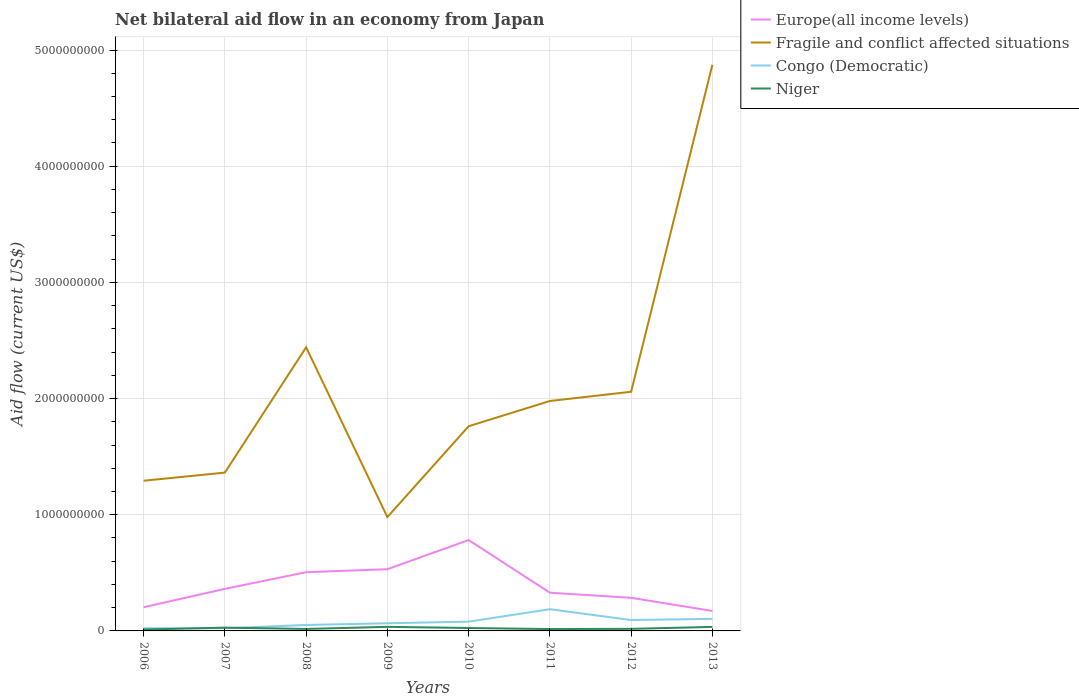How many different coloured lines are there?
Ensure brevity in your answer.  4. Across all years, what is the maximum net bilateral aid flow in Fragile and conflict affected situations?
Your response must be concise. 9.80e+08. In which year was the net bilateral aid flow in Europe(all income levels) maximum?
Offer a very short reply. 2013. What is the total net bilateral aid flow in Europe(all income levels) in the graph?
Give a very brief answer. 2.02e+08. What is the difference between the highest and the second highest net bilateral aid flow in Niger?
Give a very brief answer. 2.30e+07. What is the difference between the highest and the lowest net bilateral aid flow in Congo (Democratic)?
Provide a short and direct response. 4. How many lines are there?
Your answer should be compact. 4. How many years are there in the graph?
Give a very brief answer. 8. Where does the legend appear in the graph?
Keep it short and to the point. Top right. How many legend labels are there?
Your response must be concise. 4. How are the legend labels stacked?
Offer a terse response. Vertical. What is the title of the graph?
Your response must be concise. Net bilateral aid flow in an economy from Japan. Does "High income: OECD" appear as one of the legend labels in the graph?
Make the answer very short. No. What is the label or title of the X-axis?
Give a very brief answer. Years. What is the label or title of the Y-axis?
Your answer should be very brief. Aid flow (current US$). What is the Aid flow (current US$) in Europe(all income levels) in 2006?
Keep it short and to the point. 2.04e+08. What is the Aid flow (current US$) in Fragile and conflict affected situations in 2006?
Offer a terse response. 1.29e+09. What is the Aid flow (current US$) in Congo (Democratic) in 2006?
Your answer should be very brief. 2.32e+07. What is the Aid flow (current US$) in Niger in 2006?
Ensure brevity in your answer.  1.21e+07. What is the Aid flow (current US$) in Europe(all income levels) in 2007?
Your answer should be compact. 3.62e+08. What is the Aid flow (current US$) of Fragile and conflict affected situations in 2007?
Keep it short and to the point. 1.36e+09. What is the Aid flow (current US$) of Congo (Democratic) in 2007?
Ensure brevity in your answer.  2.29e+07. What is the Aid flow (current US$) in Niger in 2007?
Your answer should be very brief. 2.83e+07. What is the Aid flow (current US$) in Europe(all income levels) in 2008?
Ensure brevity in your answer.  5.05e+08. What is the Aid flow (current US$) of Fragile and conflict affected situations in 2008?
Your answer should be compact. 2.44e+09. What is the Aid flow (current US$) of Congo (Democratic) in 2008?
Offer a terse response. 5.12e+07. What is the Aid flow (current US$) of Niger in 2008?
Make the answer very short. 1.69e+07. What is the Aid flow (current US$) in Europe(all income levels) in 2009?
Provide a succinct answer. 5.31e+08. What is the Aid flow (current US$) of Fragile and conflict affected situations in 2009?
Offer a very short reply. 9.80e+08. What is the Aid flow (current US$) of Congo (Democratic) in 2009?
Your answer should be compact. 6.57e+07. What is the Aid flow (current US$) in Niger in 2009?
Ensure brevity in your answer.  3.51e+07. What is the Aid flow (current US$) in Europe(all income levels) in 2010?
Keep it short and to the point. 7.82e+08. What is the Aid flow (current US$) of Fragile and conflict affected situations in 2010?
Your answer should be very brief. 1.76e+09. What is the Aid flow (current US$) of Congo (Democratic) in 2010?
Provide a succinct answer. 8.00e+07. What is the Aid flow (current US$) in Niger in 2010?
Provide a short and direct response. 2.52e+07. What is the Aid flow (current US$) of Europe(all income levels) in 2011?
Your response must be concise. 3.29e+08. What is the Aid flow (current US$) in Fragile and conflict affected situations in 2011?
Ensure brevity in your answer.  1.98e+09. What is the Aid flow (current US$) of Congo (Democratic) in 2011?
Offer a terse response. 1.87e+08. What is the Aid flow (current US$) of Niger in 2011?
Your response must be concise. 1.59e+07. What is the Aid flow (current US$) in Europe(all income levels) in 2012?
Offer a very short reply. 2.85e+08. What is the Aid flow (current US$) of Fragile and conflict affected situations in 2012?
Keep it short and to the point. 2.06e+09. What is the Aid flow (current US$) in Congo (Democratic) in 2012?
Provide a succinct answer. 9.39e+07. What is the Aid flow (current US$) of Niger in 2012?
Offer a very short reply. 1.79e+07. What is the Aid flow (current US$) of Europe(all income levels) in 2013?
Make the answer very short. 1.72e+08. What is the Aid flow (current US$) in Fragile and conflict affected situations in 2013?
Your answer should be compact. 4.87e+09. What is the Aid flow (current US$) of Congo (Democratic) in 2013?
Make the answer very short. 1.04e+08. What is the Aid flow (current US$) of Niger in 2013?
Give a very brief answer. 3.45e+07. Across all years, what is the maximum Aid flow (current US$) in Europe(all income levels)?
Offer a terse response. 7.82e+08. Across all years, what is the maximum Aid flow (current US$) in Fragile and conflict affected situations?
Offer a very short reply. 4.87e+09. Across all years, what is the maximum Aid flow (current US$) of Congo (Democratic)?
Keep it short and to the point. 1.87e+08. Across all years, what is the maximum Aid flow (current US$) in Niger?
Your response must be concise. 3.51e+07. Across all years, what is the minimum Aid flow (current US$) of Europe(all income levels)?
Ensure brevity in your answer.  1.72e+08. Across all years, what is the minimum Aid flow (current US$) of Fragile and conflict affected situations?
Your answer should be very brief. 9.80e+08. Across all years, what is the minimum Aid flow (current US$) in Congo (Democratic)?
Your answer should be very brief. 2.29e+07. Across all years, what is the minimum Aid flow (current US$) in Niger?
Make the answer very short. 1.21e+07. What is the total Aid flow (current US$) of Europe(all income levels) in the graph?
Your answer should be compact. 3.17e+09. What is the total Aid flow (current US$) of Fragile and conflict affected situations in the graph?
Your response must be concise. 1.67e+1. What is the total Aid flow (current US$) in Congo (Democratic) in the graph?
Provide a short and direct response. 6.27e+08. What is the total Aid flow (current US$) of Niger in the graph?
Your answer should be very brief. 1.86e+08. What is the difference between the Aid flow (current US$) in Europe(all income levels) in 2006 and that in 2007?
Make the answer very short. -1.58e+08. What is the difference between the Aid flow (current US$) of Fragile and conflict affected situations in 2006 and that in 2007?
Your response must be concise. -7.00e+07. What is the difference between the Aid flow (current US$) of Congo (Democratic) in 2006 and that in 2007?
Your answer should be very brief. 2.30e+05. What is the difference between the Aid flow (current US$) in Niger in 2006 and that in 2007?
Provide a succinct answer. -1.62e+07. What is the difference between the Aid flow (current US$) in Europe(all income levels) in 2006 and that in 2008?
Offer a very short reply. -3.01e+08. What is the difference between the Aid flow (current US$) of Fragile and conflict affected situations in 2006 and that in 2008?
Your answer should be very brief. -1.15e+09. What is the difference between the Aid flow (current US$) in Congo (Democratic) in 2006 and that in 2008?
Your answer should be compact. -2.81e+07. What is the difference between the Aid flow (current US$) in Niger in 2006 and that in 2008?
Provide a short and direct response. -4.84e+06. What is the difference between the Aid flow (current US$) in Europe(all income levels) in 2006 and that in 2009?
Your answer should be compact. -3.27e+08. What is the difference between the Aid flow (current US$) of Fragile and conflict affected situations in 2006 and that in 2009?
Your answer should be very brief. 3.13e+08. What is the difference between the Aid flow (current US$) of Congo (Democratic) in 2006 and that in 2009?
Keep it short and to the point. -4.25e+07. What is the difference between the Aid flow (current US$) in Niger in 2006 and that in 2009?
Offer a terse response. -2.30e+07. What is the difference between the Aid flow (current US$) of Europe(all income levels) in 2006 and that in 2010?
Your answer should be compact. -5.78e+08. What is the difference between the Aid flow (current US$) of Fragile and conflict affected situations in 2006 and that in 2010?
Offer a very short reply. -4.69e+08. What is the difference between the Aid flow (current US$) of Congo (Democratic) in 2006 and that in 2010?
Your answer should be compact. -5.68e+07. What is the difference between the Aid flow (current US$) in Niger in 2006 and that in 2010?
Give a very brief answer. -1.31e+07. What is the difference between the Aid flow (current US$) of Europe(all income levels) in 2006 and that in 2011?
Your answer should be very brief. -1.25e+08. What is the difference between the Aid flow (current US$) of Fragile and conflict affected situations in 2006 and that in 2011?
Your response must be concise. -6.86e+08. What is the difference between the Aid flow (current US$) of Congo (Democratic) in 2006 and that in 2011?
Ensure brevity in your answer.  -1.64e+08. What is the difference between the Aid flow (current US$) of Niger in 2006 and that in 2011?
Keep it short and to the point. -3.77e+06. What is the difference between the Aid flow (current US$) in Europe(all income levels) in 2006 and that in 2012?
Provide a short and direct response. -8.10e+07. What is the difference between the Aid flow (current US$) of Fragile and conflict affected situations in 2006 and that in 2012?
Keep it short and to the point. -7.66e+08. What is the difference between the Aid flow (current US$) in Congo (Democratic) in 2006 and that in 2012?
Offer a terse response. -7.07e+07. What is the difference between the Aid flow (current US$) in Niger in 2006 and that in 2012?
Make the answer very short. -5.77e+06. What is the difference between the Aid flow (current US$) in Europe(all income levels) in 2006 and that in 2013?
Offer a terse response. 3.23e+07. What is the difference between the Aid flow (current US$) of Fragile and conflict affected situations in 2006 and that in 2013?
Offer a terse response. -3.58e+09. What is the difference between the Aid flow (current US$) in Congo (Democratic) in 2006 and that in 2013?
Provide a short and direct response. -8.06e+07. What is the difference between the Aid flow (current US$) of Niger in 2006 and that in 2013?
Provide a succinct answer. -2.24e+07. What is the difference between the Aid flow (current US$) in Europe(all income levels) in 2007 and that in 2008?
Provide a short and direct response. -1.43e+08. What is the difference between the Aid flow (current US$) in Fragile and conflict affected situations in 2007 and that in 2008?
Your response must be concise. -1.08e+09. What is the difference between the Aid flow (current US$) of Congo (Democratic) in 2007 and that in 2008?
Provide a succinct answer. -2.83e+07. What is the difference between the Aid flow (current US$) of Niger in 2007 and that in 2008?
Keep it short and to the point. 1.14e+07. What is the difference between the Aid flow (current US$) of Europe(all income levels) in 2007 and that in 2009?
Ensure brevity in your answer.  -1.69e+08. What is the difference between the Aid flow (current US$) in Fragile and conflict affected situations in 2007 and that in 2009?
Ensure brevity in your answer.  3.83e+08. What is the difference between the Aid flow (current US$) of Congo (Democratic) in 2007 and that in 2009?
Give a very brief answer. -4.28e+07. What is the difference between the Aid flow (current US$) in Niger in 2007 and that in 2009?
Provide a short and direct response. -6.78e+06. What is the difference between the Aid flow (current US$) of Europe(all income levels) in 2007 and that in 2010?
Your answer should be very brief. -4.20e+08. What is the difference between the Aid flow (current US$) in Fragile and conflict affected situations in 2007 and that in 2010?
Provide a succinct answer. -3.99e+08. What is the difference between the Aid flow (current US$) in Congo (Democratic) in 2007 and that in 2010?
Your answer should be compact. -5.71e+07. What is the difference between the Aid flow (current US$) of Niger in 2007 and that in 2010?
Give a very brief answer. 3.12e+06. What is the difference between the Aid flow (current US$) in Europe(all income levels) in 2007 and that in 2011?
Your answer should be very brief. 3.29e+07. What is the difference between the Aid flow (current US$) in Fragile and conflict affected situations in 2007 and that in 2011?
Keep it short and to the point. -6.16e+08. What is the difference between the Aid flow (current US$) of Congo (Democratic) in 2007 and that in 2011?
Keep it short and to the point. -1.64e+08. What is the difference between the Aid flow (current US$) in Niger in 2007 and that in 2011?
Your answer should be compact. 1.24e+07. What is the difference between the Aid flow (current US$) of Europe(all income levels) in 2007 and that in 2012?
Provide a succinct answer. 7.69e+07. What is the difference between the Aid flow (current US$) of Fragile and conflict affected situations in 2007 and that in 2012?
Your answer should be compact. -6.96e+08. What is the difference between the Aid flow (current US$) of Congo (Democratic) in 2007 and that in 2012?
Keep it short and to the point. -7.09e+07. What is the difference between the Aid flow (current US$) of Niger in 2007 and that in 2012?
Make the answer very short. 1.04e+07. What is the difference between the Aid flow (current US$) in Europe(all income levels) in 2007 and that in 2013?
Offer a very short reply. 1.90e+08. What is the difference between the Aid flow (current US$) in Fragile and conflict affected situations in 2007 and that in 2013?
Your answer should be very brief. -3.51e+09. What is the difference between the Aid flow (current US$) in Congo (Democratic) in 2007 and that in 2013?
Provide a succinct answer. -8.09e+07. What is the difference between the Aid flow (current US$) in Niger in 2007 and that in 2013?
Make the answer very short. -6.19e+06. What is the difference between the Aid flow (current US$) of Europe(all income levels) in 2008 and that in 2009?
Offer a terse response. -2.58e+07. What is the difference between the Aid flow (current US$) in Fragile and conflict affected situations in 2008 and that in 2009?
Offer a terse response. 1.46e+09. What is the difference between the Aid flow (current US$) of Congo (Democratic) in 2008 and that in 2009?
Offer a terse response. -1.45e+07. What is the difference between the Aid flow (current US$) in Niger in 2008 and that in 2009?
Offer a terse response. -1.81e+07. What is the difference between the Aid flow (current US$) of Europe(all income levels) in 2008 and that in 2010?
Provide a short and direct response. -2.77e+08. What is the difference between the Aid flow (current US$) in Fragile and conflict affected situations in 2008 and that in 2010?
Your answer should be compact. 6.80e+08. What is the difference between the Aid flow (current US$) in Congo (Democratic) in 2008 and that in 2010?
Offer a very short reply. -2.88e+07. What is the difference between the Aid flow (current US$) of Niger in 2008 and that in 2010?
Your response must be concise. -8.23e+06. What is the difference between the Aid flow (current US$) in Europe(all income levels) in 2008 and that in 2011?
Your answer should be very brief. 1.76e+08. What is the difference between the Aid flow (current US$) of Fragile and conflict affected situations in 2008 and that in 2011?
Ensure brevity in your answer.  4.62e+08. What is the difference between the Aid flow (current US$) in Congo (Democratic) in 2008 and that in 2011?
Keep it short and to the point. -1.36e+08. What is the difference between the Aid flow (current US$) in Niger in 2008 and that in 2011?
Make the answer very short. 1.07e+06. What is the difference between the Aid flow (current US$) in Europe(all income levels) in 2008 and that in 2012?
Your answer should be compact. 2.20e+08. What is the difference between the Aid flow (current US$) in Fragile and conflict affected situations in 2008 and that in 2012?
Give a very brief answer. 3.83e+08. What is the difference between the Aid flow (current US$) in Congo (Democratic) in 2008 and that in 2012?
Your answer should be very brief. -4.26e+07. What is the difference between the Aid flow (current US$) in Niger in 2008 and that in 2012?
Your answer should be very brief. -9.30e+05. What is the difference between the Aid flow (current US$) of Europe(all income levels) in 2008 and that in 2013?
Offer a terse response. 3.34e+08. What is the difference between the Aid flow (current US$) in Fragile and conflict affected situations in 2008 and that in 2013?
Ensure brevity in your answer.  -2.43e+09. What is the difference between the Aid flow (current US$) in Congo (Democratic) in 2008 and that in 2013?
Ensure brevity in your answer.  -5.26e+07. What is the difference between the Aid flow (current US$) in Niger in 2008 and that in 2013?
Provide a short and direct response. -1.75e+07. What is the difference between the Aid flow (current US$) of Europe(all income levels) in 2009 and that in 2010?
Provide a succinct answer. -2.51e+08. What is the difference between the Aid flow (current US$) of Fragile and conflict affected situations in 2009 and that in 2010?
Offer a terse response. -7.82e+08. What is the difference between the Aid flow (current US$) of Congo (Democratic) in 2009 and that in 2010?
Your answer should be very brief. -1.43e+07. What is the difference between the Aid flow (current US$) in Niger in 2009 and that in 2010?
Keep it short and to the point. 9.90e+06. What is the difference between the Aid flow (current US$) of Europe(all income levels) in 2009 and that in 2011?
Provide a succinct answer. 2.02e+08. What is the difference between the Aid flow (current US$) in Fragile and conflict affected situations in 2009 and that in 2011?
Make the answer very short. -9.99e+08. What is the difference between the Aid flow (current US$) in Congo (Democratic) in 2009 and that in 2011?
Provide a succinct answer. -1.21e+08. What is the difference between the Aid flow (current US$) of Niger in 2009 and that in 2011?
Your answer should be very brief. 1.92e+07. What is the difference between the Aid flow (current US$) in Europe(all income levels) in 2009 and that in 2012?
Your response must be concise. 2.46e+08. What is the difference between the Aid flow (current US$) of Fragile and conflict affected situations in 2009 and that in 2012?
Your response must be concise. -1.08e+09. What is the difference between the Aid flow (current US$) in Congo (Democratic) in 2009 and that in 2012?
Give a very brief answer. -2.82e+07. What is the difference between the Aid flow (current US$) in Niger in 2009 and that in 2012?
Your response must be concise. 1.72e+07. What is the difference between the Aid flow (current US$) in Europe(all income levels) in 2009 and that in 2013?
Offer a terse response. 3.60e+08. What is the difference between the Aid flow (current US$) in Fragile and conflict affected situations in 2009 and that in 2013?
Keep it short and to the point. -3.89e+09. What is the difference between the Aid flow (current US$) in Congo (Democratic) in 2009 and that in 2013?
Provide a short and direct response. -3.81e+07. What is the difference between the Aid flow (current US$) of Niger in 2009 and that in 2013?
Your answer should be very brief. 5.90e+05. What is the difference between the Aid flow (current US$) of Europe(all income levels) in 2010 and that in 2011?
Your response must be concise. 4.53e+08. What is the difference between the Aid flow (current US$) of Fragile and conflict affected situations in 2010 and that in 2011?
Your answer should be compact. -2.17e+08. What is the difference between the Aid flow (current US$) in Congo (Democratic) in 2010 and that in 2011?
Give a very brief answer. -1.07e+08. What is the difference between the Aid flow (current US$) in Niger in 2010 and that in 2011?
Your answer should be very brief. 9.30e+06. What is the difference between the Aid flow (current US$) of Europe(all income levels) in 2010 and that in 2012?
Provide a succinct answer. 4.97e+08. What is the difference between the Aid flow (current US$) in Fragile and conflict affected situations in 2010 and that in 2012?
Make the answer very short. -2.97e+08. What is the difference between the Aid flow (current US$) of Congo (Democratic) in 2010 and that in 2012?
Make the answer very short. -1.39e+07. What is the difference between the Aid flow (current US$) in Niger in 2010 and that in 2012?
Offer a very short reply. 7.30e+06. What is the difference between the Aid flow (current US$) of Europe(all income levels) in 2010 and that in 2013?
Give a very brief answer. 6.10e+08. What is the difference between the Aid flow (current US$) in Fragile and conflict affected situations in 2010 and that in 2013?
Make the answer very short. -3.11e+09. What is the difference between the Aid flow (current US$) of Congo (Democratic) in 2010 and that in 2013?
Your answer should be very brief. -2.38e+07. What is the difference between the Aid flow (current US$) of Niger in 2010 and that in 2013?
Offer a very short reply. -9.31e+06. What is the difference between the Aid flow (current US$) of Europe(all income levels) in 2011 and that in 2012?
Provide a short and direct response. 4.40e+07. What is the difference between the Aid flow (current US$) in Fragile and conflict affected situations in 2011 and that in 2012?
Provide a succinct answer. -7.96e+07. What is the difference between the Aid flow (current US$) of Congo (Democratic) in 2011 and that in 2012?
Offer a terse response. 9.29e+07. What is the difference between the Aid flow (current US$) in Niger in 2011 and that in 2012?
Your answer should be compact. -2.00e+06. What is the difference between the Aid flow (current US$) in Europe(all income levels) in 2011 and that in 2013?
Give a very brief answer. 1.57e+08. What is the difference between the Aid flow (current US$) in Fragile and conflict affected situations in 2011 and that in 2013?
Provide a succinct answer. -2.89e+09. What is the difference between the Aid flow (current US$) in Congo (Democratic) in 2011 and that in 2013?
Keep it short and to the point. 8.30e+07. What is the difference between the Aid flow (current US$) in Niger in 2011 and that in 2013?
Your answer should be very brief. -1.86e+07. What is the difference between the Aid flow (current US$) in Europe(all income levels) in 2012 and that in 2013?
Make the answer very short. 1.13e+08. What is the difference between the Aid flow (current US$) of Fragile and conflict affected situations in 2012 and that in 2013?
Offer a terse response. -2.81e+09. What is the difference between the Aid flow (current US$) of Congo (Democratic) in 2012 and that in 2013?
Your answer should be very brief. -9.93e+06. What is the difference between the Aid flow (current US$) of Niger in 2012 and that in 2013?
Your response must be concise. -1.66e+07. What is the difference between the Aid flow (current US$) of Europe(all income levels) in 2006 and the Aid flow (current US$) of Fragile and conflict affected situations in 2007?
Provide a succinct answer. -1.16e+09. What is the difference between the Aid flow (current US$) of Europe(all income levels) in 2006 and the Aid flow (current US$) of Congo (Democratic) in 2007?
Ensure brevity in your answer.  1.81e+08. What is the difference between the Aid flow (current US$) of Europe(all income levels) in 2006 and the Aid flow (current US$) of Niger in 2007?
Your answer should be very brief. 1.76e+08. What is the difference between the Aid flow (current US$) in Fragile and conflict affected situations in 2006 and the Aid flow (current US$) in Congo (Democratic) in 2007?
Your answer should be compact. 1.27e+09. What is the difference between the Aid flow (current US$) of Fragile and conflict affected situations in 2006 and the Aid flow (current US$) of Niger in 2007?
Provide a succinct answer. 1.26e+09. What is the difference between the Aid flow (current US$) in Congo (Democratic) in 2006 and the Aid flow (current US$) in Niger in 2007?
Offer a terse response. -5.12e+06. What is the difference between the Aid flow (current US$) in Europe(all income levels) in 2006 and the Aid flow (current US$) in Fragile and conflict affected situations in 2008?
Keep it short and to the point. -2.24e+09. What is the difference between the Aid flow (current US$) of Europe(all income levels) in 2006 and the Aid flow (current US$) of Congo (Democratic) in 2008?
Give a very brief answer. 1.53e+08. What is the difference between the Aid flow (current US$) of Europe(all income levels) in 2006 and the Aid flow (current US$) of Niger in 2008?
Your answer should be compact. 1.87e+08. What is the difference between the Aid flow (current US$) of Fragile and conflict affected situations in 2006 and the Aid flow (current US$) of Congo (Democratic) in 2008?
Offer a very short reply. 1.24e+09. What is the difference between the Aid flow (current US$) in Fragile and conflict affected situations in 2006 and the Aid flow (current US$) in Niger in 2008?
Make the answer very short. 1.28e+09. What is the difference between the Aid flow (current US$) of Congo (Democratic) in 2006 and the Aid flow (current US$) of Niger in 2008?
Give a very brief answer. 6.23e+06. What is the difference between the Aid flow (current US$) of Europe(all income levels) in 2006 and the Aid flow (current US$) of Fragile and conflict affected situations in 2009?
Offer a very short reply. -7.76e+08. What is the difference between the Aid flow (current US$) in Europe(all income levels) in 2006 and the Aid flow (current US$) in Congo (Democratic) in 2009?
Provide a succinct answer. 1.38e+08. What is the difference between the Aid flow (current US$) in Europe(all income levels) in 2006 and the Aid flow (current US$) in Niger in 2009?
Offer a very short reply. 1.69e+08. What is the difference between the Aid flow (current US$) of Fragile and conflict affected situations in 2006 and the Aid flow (current US$) of Congo (Democratic) in 2009?
Your answer should be very brief. 1.23e+09. What is the difference between the Aid flow (current US$) of Fragile and conflict affected situations in 2006 and the Aid flow (current US$) of Niger in 2009?
Your response must be concise. 1.26e+09. What is the difference between the Aid flow (current US$) of Congo (Democratic) in 2006 and the Aid flow (current US$) of Niger in 2009?
Keep it short and to the point. -1.19e+07. What is the difference between the Aid flow (current US$) of Europe(all income levels) in 2006 and the Aid flow (current US$) of Fragile and conflict affected situations in 2010?
Your response must be concise. -1.56e+09. What is the difference between the Aid flow (current US$) in Europe(all income levels) in 2006 and the Aid flow (current US$) in Congo (Democratic) in 2010?
Ensure brevity in your answer.  1.24e+08. What is the difference between the Aid flow (current US$) of Europe(all income levels) in 2006 and the Aid flow (current US$) of Niger in 2010?
Your answer should be compact. 1.79e+08. What is the difference between the Aid flow (current US$) of Fragile and conflict affected situations in 2006 and the Aid flow (current US$) of Congo (Democratic) in 2010?
Make the answer very short. 1.21e+09. What is the difference between the Aid flow (current US$) of Fragile and conflict affected situations in 2006 and the Aid flow (current US$) of Niger in 2010?
Make the answer very short. 1.27e+09. What is the difference between the Aid flow (current US$) of Congo (Democratic) in 2006 and the Aid flow (current US$) of Niger in 2010?
Give a very brief answer. -2.00e+06. What is the difference between the Aid flow (current US$) in Europe(all income levels) in 2006 and the Aid flow (current US$) in Fragile and conflict affected situations in 2011?
Your response must be concise. -1.77e+09. What is the difference between the Aid flow (current US$) in Europe(all income levels) in 2006 and the Aid flow (current US$) in Congo (Democratic) in 2011?
Make the answer very short. 1.73e+07. What is the difference between the Aid flow (current US$) of Europe(all income levels) in 2006 and the Aid flow (current US$) of Niger in 2011?
Your answer should be very brief. 1.88e+08. What is the difference between the Aid flow (current US$) in Fragile and conflict affected situations in 2006 and the Aid flow (current US$) in Congo (Democratic) in 2011?
Give a very brief answer. 1.11e+09. What is the difference between the Aid flow (current US$) of Fragile and conflict affected situations in 2006 and the Aid flow (current US$) of Niger in 2011?
Your answer should be compact. 1.28e+09. What is the difference between the Aid flow (current US$) of Congo (Democratic) in 2006 and the Aid flow (current US$) of Niger in 2011?
Make the answer very short. 7.30e+06. What is the difference between the Aid flow (current US$) in Europe(all income levels) in 2006 and the Aid flow (current US$) in Fragile and conflict affected situations in 2012?
Make the answer very short. -1.85e+09. What is the difference between the Aid flow (current US$) of Europe(all income levels) in 2006 and the Aid flow (current US$) of Congo (Democratic) in 2012?
Your answer should be very brief. 1.10e+08. What is the difference between the Aid flow (current US$) in Europe(all income levels) in 2006 and the Aid flow (current US$) in Niger in 2012?
Your response must be concise. 1.86e+08. What is the difference between the Aid flow (current US$) of Fragile and conflict affected situations in 2006 and the Aid flow (current US$) of Congo (Democratic) in 2012?
Offer a terse response. 1.20e+09. What is the difference between the Aid flow (current US$) in Fragile and conflict affected situations in 2006 and the Aid flow (current US$) in Niger in 2012?
Give a very brief answer. 1.27e+09. What is the difference between the Aid flow (current US$) in Congo (Democratic) in 2006 and the Aid flow (current US$) in Niger in 2012?
Provide a succinct answer. 5.30e+06. What is the difference between the Aid flow (current US$) of Europe(all income levels) in 2006 and the Aid flow (current US$) of Fragile and conflict affected situations in 2013?
Your answer should be compact. -4.67e+09. What is the difference between the Aid flow (current US$) of Europe(all income levels) in 2006 and the Aid flow (current US$) of Congo (Democratic) in 2013?
Your answer should be compact. 1.00e+08. What is the difference between the Aid flow (current US$) of Europe(all income levels) in 2006 and the Aid flow (current US$) of Niger in 2013?
Your response must be concise. 1.70e+08. What is the difference between the Aid flow (current US$) in Fragile and conflict affected situations in 2006 and the Aid flow (current US$) in Congo (Democratic) in 2013?
Offer a very short reply. 1.19e+09. What is the difference between the Aid flow (current US$) of Fragile and conflict affected situations in 2006 and the Aid flow (current US$) of Niger in 2013?
Offer a very short reply. 1.26e+09. What is the difference between the Aid flow (current US$) of Congo (Democratic) in 2006 and the Aid flow (current US$) of Niger in 2013?
Make the answer very short. -1.13e+07. What is the difference between the Aid flow (current US$) of Europe(all income levels) in 2007 and the Aid flow (current US$) of Fragile and conflict affected situations in 2008?
Your answer should be compact. -2.08e+09. What is the difference between the Aid flow (current US$) of Europe(all income levels) in 2007 and the Aid flow (current US$) of Congo (Democratic) in 2008?
Your answer should be compact. 3.11e+08. What is the difference between the Aid flow (current US$) of Europe(all income levels) in 2007 and the Aid flow (current US$) of Niger in 2008?
Offer a very short reply. 3.45e+08. What is the difference between the Aid flow (current US$) in Fragile and conflict affected situations in 2007 and the Aid flow (current US$) in Congo (Democratic) in 2008?
Make the answer very short. 1.31e+09. What is the difference between the Aid flow (current US$) of Fragile and conflict affected situations in 2007 and the Aid flow (current US$) of Niger in 2008?
Offer a terse response. 1.35e+09. What is the difference between the Aid flow (current US$) in Congo (Democratic) in 2007 and the Aid flow (current US$) in Niger in 2008?
Provide a succinct answer. 6.00e+06. What is the difference between the Aid flow (current US$) of Europe(all income levels) in 2007 and the Aid flow (current US$) of Fragile and conflict affected situations in 2009?
Offer a very short reply. -6.18e+08. What is the difference between the Aid flow (current US$) in Europe(all income levels) in 2007 and the Aid flow (current US$) in Congo (Democratic) in 2009?
Offer a very short reply. 2.96e+08. What is the difference between the Aid flow (current US$) of Europe(all income levels) in 2007 and the Aid flow (current US$) of Niger in 2009?
Give a very brief answer. 3.27e+08. What is the difference between the Aid flow (current US$) in Fragile and conflict affected situations in 2007 and the Aid flow (current US$) in Congo (Democratic) in 2009?
Ensure brevity in your answer.  1.30e+09. What is the difference between the Aid flow (current US$) of Fragile and conflict affected situations in 2007 and the Aid flow (current US$) of Niger in 2009?
Keep it short and to the point. 1.33e+09. What is the difference between the Aid flow (current US$) in Congo (Democratic) in 2007 and the Aid flow (current US$) in Niger in 2009?
Give a very brief answer. -1.21e+07. What is the difference between the Aid flow (current US$) of Europe(all income levels) in 2007 and the Aid flow (current US$) of Fragile and conflict affected situations in 2010?
Ensure brevity in your answer.  -1.40e+09. What is the difference between the Aid flow (current US$) in Europe(all income levels) in 2007 and the Aid flow (current US$) in Congo (Democratic) in 2010?
Provide a succinct answer. 2.82e+08. What is the difference between the Aid flow (current US$) in Europe(all income levels) in 2007 and the Aid flow (current US$) in Niger in 2010?
Make the answer very short. 3.37e+08. What is the difference between the Aid flow (current US$) of Fragile and conflict affected situations in 2007 and the Aid flow (current US$) of Congo (Democratic) in 2010?
Provide a succinct answer. 1.28e+09. What is the difference between the Aid flow (current US$) of Fragile and conflict affected situations in 2007 and the Aid flow (current US$) of Niger in 2010?
Provide a short and direct response. 1.34e+09. What is the difference between the Aid flow (current US$) in Congo (Democratic) in 2007 and the Aid flow (current US$) in Niger in 2010?
Ensure brevity in your answer.  -2.23e+06. What is the difference between the Aid flow (current US$) of Europe(all income levels) in 2007 and the Aid flow (current US$) of Fragile and conflict affected situations in 2011?
Give a very brief answer. -1.62e+09. What is the difference between the Aid flow (current US$) of Europe(all income levels) in 2007 and the Aid flow (current US$) of Congo (Democratic) in 2011?
Ensure brevity in your answer.  1.75e+08. What is the difference between the Aid flow (current US$) of Europe(all income levels) in 2007 and the Aid flow (current US$) of Niger in 2011?
Offer a very short reply. 3.46e+08. What is the difference between the Aid flow (current US$) in Fragile and conflict affected situations in 2007 and the Aid flow (current US$) in Congo (Democratic) in 2011?
Provide a short and direct response. 1.18e+09. What is the difference between the Aid flow (current US$) in Fragile and conflict affected situations in 2007 and the Aid flow (current US$) in Niger in 2011?
Give a very brief answer. 1.35e+09. What is the difference between the Aid flow (current US$) of Congo (Democratic) in 2007 and the Aid flow (current US$) of Niger in 2011?
Your answer should be compact. 7.07e+06. What is the difference between the Aid flow (current US$) in Europe(all income levels) in 2007 and the Aid flow (current US$) in Fragile and conflict affected situations in 2012?
Ensure brevity in your answer.  -1.70e+09. What is the difference between the Aid flow (current US$) in Europe(all income levels) in 2007 and the Aid flow (current US$) in Congo (Democratic) in 2012?
Offer a terse response. 2.68e+08. What is the difference between the Aid flow (current US$) of Europe(all income levels) in 2007 and the Aid flow (current US$) of Niger in 2012?
Your answer should be very brief. 3.44e+08. What is the difference between the Aid flow (current US$) in Fragile and conflict affected situations in 2007 and the Aid flow (current US$) in Congo (Democratic) in 2012?
Provide a short and direct response. 1.27e+09. What is the difference between the Aid flow (current US$) of Fragile and conflict affected situations in 2007 and the Aid flow (current US$) of Niger in 2012?
Offer a terse response. 1.34e+09. What is the difference between the Aid flow (current US$) of Congo (Democratic) in 2007 and the Aid flow (current US$) of Niger in 2012?
Your answer should be very brief. 5.07e+06. What is the difference between the Aid flow (current US$) of Europe(all income levels) in 2007 and the Aid flow (current US$) of Fragile and conflict affected situations in 2013?
Keep it short and to the point. -4.51e+09. What is the difference between the Aid flow (current US$) in Europe(all income levels) in 2007 and the Aid flow (current US$) in Congo (Democratic) in 2013?
Your response must be concise. 2.58e+08. What is the difference between the Aid flow (current US$) of Europe(all income levels) in 2007 and the Aid flow (current US$) of Niger in 2013?
Offer a terse response. 3.27e+08. What is the difference between the Aid flow (current US$) in Fragile and conflict affected situations in 2007 and the Aid flow (current US$) in Congo (Democratic) in 2013?
Your answer should be compact. 1.26e+09. What is the difference between the Aid flow (current US$) of Fragile and conflict affected situations in 2007 and the Aid flow (current US$) of Niger in 2013?
Make the answer very short. 1.33e+09. What is the difference between the Aid flow (current US$) in Congo (Democratic) in 2007 and the Aid flow (current US$) in Niger in 2013?
Provide a short and direct response. -1.15e+07. What is the difference between the Aid flow (current US$) in Europe(all income levels) in 2008 and the Aid flow (current US$) in Fragile and conflict affected situations in 2009?
Provide a succinct answer. -4.74e+08. What is the difference between the Aid flow (current US$) in Europe(all income levels) in 2008 and the Aid flow (current US$) in Congo (Democratic) in 2009?
Provide a succinct answer. 4.40e+08. What is the difference between the Aid flow (current US$) of Europe(all income levels) in 2008 and the Aid flow (current US$) of Niger in 2009?
Your answer should be very brief. 4.70e+08. What is the difference between the Aid flow (current US$) in Fragile and conflict affected situations in 2008 and the Aid flow (current US$) in Congo (Democratic) in 2009?
Provide a succinct answer. 2.38e+09. What is the difference between the Aid flow (current US$) in Fragile and conflict affected situations in 2008 and the Aid flow (current US$) in Niger in 2009?
Keep it short and to the point. 2.41e+09. What is the difference between the Aid flow (current US$) of Congo (Democratic) in 2008 and the Aid flow (current US$) of Niger in 2009?
Make the answer very short. 1.62e+07. What is the difference between the Aid flow (current US$) of Europe(all income levels) in 2008 and the Aid flow (current US$) of Fragile and conflict affected situations in 2010?
Provide a succinct answer. -1.26e+09. What is the difference between the Aid flow (current US$) in Europe(all income levels) in 2008 and the Aid flow (current US$) in Congo (Democratic) in 2010?
Keep it short and to the point. 4.25e+08. What is the difference between the Aid flow (current US$) of Europe(all income levels) in 2008 and the Aid flow (current US$) of Niger in 2010?
Provide a succinct answer. 4.80e+08. What is the difference between the Aid flow (current US$) of Fragile and conflict affected situations in 2008 and the Aid flow (current US$) of Congo (Democratic) in 2010?
Your response must be concise. 2.36e+09. What is the difference between the Aid flow (current US$) of Fragile and conflict affected situations in 2008 and the Aid flow (current US$) of Niger in 2010?
Your answer should be compact. 2.42e+09. What is the difference between the Aid flow (current US$) in Congo (Democratic) in 2008 and the Aid flow (current US$) in Niger in 2010?
Your response must be concise. 2.61e+07. What is the difference between the Aid flow (current US$) in Europe(all income levels) in 2008 and the Aid flow (current US$) in Fragile and conflict affected situations in 2011?
Your answer should be compact. -1.47e+09. What is the difference between the Aid flow (current US$) of Europe(all income levels) in 2008 and the Aid flow (current US$) of Congo (Democratic) in 2011?
Your response must be concise. 3.19e+08. What is the difference between the Aid flow (current US$) of Europe(all income levels) in 2008 and the Aid flow (current US$) of Niger in 2011?
Offer a very short reply. 4.90e+08. What is the difference between the Aid flow (current US$) of Fragile and conflict affected situations in 2008 and the Aid flow (current US$) of Congo (Democratic) in 2011?
Provide a short and direct response. 2.25e+09. What is the difference between the Aid flow (current US$) in Fragile and conflict affected situations in 2008 and the Aid flow (current US$) in Niger in 2011?
Offer a terse response. 2.43e+09. What is the difference between the Aid flow (current US$) of Congo (Democratic) in 2008 and the Aid flow (current US$) of Niger in 2011?
Give a very brief answer. 3.54e+07. What is the difference between the Aid flow (current US$) of Europe(all income levels) in 2008 and the Aid flow (current US$) of Fragile and conflict affected situations in 2012?
Offer a terse response. -1.55e+09. What is the difference between the Aid flow (current US$) of Europe(all income levels) in 2008 and the Aid flow (current US$) of Congo (Democratic) in 2012?
Keep it short and to the point. 4.12e+08. What is the difference between the Aid flow (current US$) in Europe(all income levels) in 2008 and the Aid flow (current US$) in Niger in 2012?
Offer a terse response. 4.88e+08. What is the difference between the Aid flow (current US$) of Fragile and conflict affected situations in 2008 and the Aid flow (current US$) of Congo (Democratic) in 2012?
Make the answer very short. 2.35e+09. What is the difference between the Aid flow (current US$) of Fragile and conflict affected situations in 2008 and the Aid flow (current US$) of Niger in 2012?
Your response must be concise. 2.42e+09. What is the difference between the Aid flow (current US$) of Congo (Democratic) in 2008 and the Aid flow (current US$) of Niger in 2012?
Make the answer very short. 3.34e+07. What is the difference between the Aid flow (current US$) of Europe(all income levels) in 2008 and the Aid flow (current US$) of Fragile and conflict affected situations in 2013?
Offer a terse response. -4.37e+09. What is the difference between the Aid flow (current US$) of Europe(all income levels) in 2008 and the Aid flow (current US$) of Congo (Democratic) in 2013?
Offer a very short reply. 4.02e+08. What is the difference between the Aid flow (current US$) of Europe(all income levels) in 2008 and the Aid flow (current US$) of Niger in 2013?
Offer a very short reply. 4.71e+08. What is the difference between the Aid flow (current US$) in Fragile and conflict affected situations in 2008 and the Aid flow (current US$) in Congo (Democratic) in 2013?
Your response must be concise. 2.34e+09. What is the difference between the Aid flow (current US$) in Fragile and conflict affected situations in 2008 and the Aid flow (current US$) in Niger in 2013?
Make the answer very short. 2.41e+09. What is the difference between the Aid flow (current US$) in Congo (Democratic) in 2008 and the Aid flow (current US$) in Niger in 2013?
Keep it short and to the point. 1.68e+07. What is the difference between the Aid flow (current US$) of Europe(all income levels) in 2009 and the Aid flow (current US$) of Fragile and conflict affected situations in 2010?
Offer a very short reply. -1.23e+09. What is the difference between the Aid flow (current US$) in Europe(all income levels) in 2009 and the Aid flow (current US$) in Congo (Democratic) in 2010?
Provide a succinct answer. 4.51e+08. What is the difference between the Aid flow (current US$) in Europe(all income levels) in 2009 and the Aid flow (current US$) in Niger in 2010?
Provide a succinct answer. 5.06e+08. What is the difference between the Aid flow (current US$) of Fragile and conflict affected situations in 2009 and the Aid flow (current US$) of Congo (Democratic) in 2010?
Offer a terse response. 9.00e+08. What is the difference between the Aid flow (current US$) of Fragile and conflict affected situations in 2009 and the Aid flow (current US$) of Niger in 2010?
Ensure brevity in your answer.  9.54e+08. What is the difference between the Aid flow (current US$) in Congo (Democratic) in 2009 and the Aid flow (current US$) in Niger in 2010?
Keep it short and to the point. 4.05e+07. What is the difference between the Aid flow (current US$) in Europe(all income levels) in 2009 and the Aid flow (current US$) in Fragile and conflict affected situations in 2011?
Give a very brief answer. -1.45e+09. What is the difference between the Aid flow (current US$) in Europe(all income levels) in 2009 and the Aid flow (current US$) in Congo (Democratic) in 2011?
Make the answer very short. 3.45e+08. What is the difference between the Aid flow (current US$) of Europe(all income levels) in 2009 and the Aid flow (current US$) of Niger in 2011?
Your response must be concise. 5.15e+08. What is the difference between the Aid flow (current US$) of Fragile and conflict affected situations in 2009 and the Aid flow (current US$) of Congo (Democratic) in 2011?
Your response must be concise. 7.93e+08. What is the difference between the Aid flow (current US$) in Fragile and conflict affected situations in 2009 and the Aid flow (current US$) in Niger in 2011?
Provide a succinct answer. 9.64e+08. What is the difference between the Aid flow (current US$) in Congo (Democratic) in 2009 and the Aid flow (current US$) in Niger in 2011?
Make the answer very short. 4.98e+07. What is the difference between the Aid flow (current US$) of Europe(all income levels) in 2009 and the Aid flow (current US$) of Fragile and conflict affected situations in 2012?
Keep it short and to the point. -1.53e+09. What is the difference between the Aid flow (current US$) of Europe(all income levels) in 2009 and the Aid flow (current US$) of Congo (Democratic) in 2012?
Give a very brief answer. 4.37e+08. What is the difference between the Aid flow (current US$) of Europe(all income levels) in 2009 and the Aid flow (current US$) of Niger in 2012?
Provide a succinct answer. 5.13e+08. What is the difference between the Aid flow (current US$) in Fragile and conflict affected situations in 2009 and the Aid flow (current US$) in Congo (Democratic) in 2012?
Provide a short and direct response. 8.86e+08. What is the difference between the Aid flow (current US$) of Fragile and conflict affected situations in 2009 and the Aid flow (current US$) of Niger in 2012?
Give a very brief answer. 9.62e+08. What is the difference between the Aid flow (current US$) of Congo (Democratic) in 2009 and the Aid flow (current US$) of Niger in 2012?
Your answer should be very brief. 4.78e+07. What is the difference between the Aid flow (current US$) of Europe(all income levels) in 2009 and the Aid flow (current US$) of Fragile and conflict affected situations in 2013?
Keep it short and to the point. -4.34e+09. What is the difference between the Aid flow (current US$) of Europe(all income levels) in 2009 and the Aid flow (current US$) of Congo (Democratic) in 2013?
Your response must be concise. 4.27e+08. What is the difference between the Aid flow (current US$) of Europe(all income levels) in 2009 and the Aid flow (current US$) of Niger in 2013?
Offer a terse response. 4.97e+08. What is the difference between the Aid flow (current US$) in Fragile and conflict affected situations in 2009 and the Aid flow (current US$) in Congo (Democratic) in 2013?
Provide a short and direct response. 8.76e+08. What is the difference between the Aid flow (current US$) of Fragile and conflict affected situations in 2009 and the Aid flow (current US$) of Niger in 2013?
Provide a short and direct response. 9.45e+08. What is the difference between the Aid flow (current US$) in Congo (Democratic) in 2009 and the Aid flow (current US$) in Niger in 2013?
Keep it short and to the point. 3.12e+07. What is the difference between the Aid flow (current US$) of Europe(all income levels) in 2010 and the Aid flow (current US$) of Fragile and conflict affected situations in 2011?
Your answer should be compact. -1.20e+09. What is the difference between the Aid flow (current US$) of Europe(all income levels) in 2010 and the Aid flow (current US$) of Congo (Democratic) in 2011?
Your answer should be compact. 5.95e+08. What is the difference between the Aid flow (current US$) in Europe(all income levels) in 2010 and the Aid flow (current US$) in Niger in 2011?
Your answer should be compact. 7.66e+08. What is the difference between the Aid flow (current US$) in Fragile and conflict affected situations in 2010 and the Aid flow (current US$) in Congo (Democratic) in 2011?
Offer a terse response. 1.58e+09. What is the difference between the Aid flow (current US$) in Fragile and conflict affected situations in 2010 and the Aid flow (current US$) in Niger in 2011?
Offer a very short reply. 1.75e+09. What is the difference between the Aid flow (current US$) of Congo (Democratic) in 2010 and the Aid flow (current US$) of Niger in 2011?
Your answer should be very brief. 6.41e+07. What is the difference between the Aid flow (current US$) of Europe(all income levels) in 2010 and the Aid flow (current US$) of Fragile and conflict affected situations in 2012?
Keep it short and to the point. -1.28e+09. What is the difference between the Aid flow (current US$) in Europe(all income levels) in 2010 and the Aid flow (current US$) in Congo (Democratic) in 2012?
Make the answer very short. 6.88e+08. What is the difference between the Aid flow (current US$) of Europe(all income levels) in 2010 and the Aid flow (current US$) of Niger in 2012?
Your response must be concise. 7.64e+08. What is the difference between the Aid flow (current US$) in Fragile and conflict affected situations in 2010 and the Aid flow (current US$) in Congo (Democratic) in 2012?
Provide a short and direct response. 1.67e+09. What is the difference between the Aid flow (current US$) of Fragile and conflict affected situations in 2010 and the Aid flow (current US$) of Niger in 2012?
Make the answer very short. 1.74e+09. What is the difference between the Aid flow (current US$) of Congo (Democratic) in 2010 and the Aid flow (current US$) of Niger in 2012?
Offer a very short reply. 6.21e+07. What is the difference between the Aid flow (current US$) in Europe(all income levels) in 2010 and the Aid flow (current US$) in Fragile and conflict affected situations in 2013?
Provide a short and direct response. -4.09e+09. What is the difference between the Aid flow (current US$) of Europe(all income levels) in 2010 and the Aid flow (current US$) of Congo (Democratic) in 2013?
Provide a short and direct response. 6.78e+08. What is the difference between the Aid flow (current US$) in Europe(all income levels) in 2010 and the Aid flow (current US$) in Niger in 2013?
Ensure brevity in your answer.  7.48e+08. What is the difference between the Aid flow (current US$) in Fragile and conflict affected situations in 2010 and the Aid flow (current US$) in Congo (Democratic) in 2013?
Offer a terse response. 1.66e+09. What is the difference between the Aid flow (current US$) of Fragile and conflict affected situations in 2010 and the Aid flow (current US$) of Niger in 2013?
Give a very brief answer. 1.73e+09. What is the difference between the Aid flow (current US$) of Congo (Democratic) in 2010 and the Aid flow (current US$) of Niger in 2013?
Keep it short and to the point. 4.55e+07. What is the difference between the Aid flow (current US$) of Europe(all income levels) in 2011 and the Aid flow (current US$) of Fragile and conflict affected situations in 2012?
Make the answer very short. -1.73e+09. What is the difference between the Aid flow (current US$) of Europe(all income levels) in 2011 and the Aid flow (current US$) of Congo (Democratic) in 2012?
Your answer should be very brief. 2.35e+08. What is the difference between the Aid flow (current US$) of Europe(all income levels) in 2011 and the Aid flow (current US$) of Niger in 2012?
Make the answer very short. 3.11e+08. What is the difference between the Aid flow (current US$) of Fragile and conflict affected situations in 2011 and the Aid flow (current US$) of Congo (Democratic) in 2012?
Your answer should be very brief. 1.89e+09. What is the difference between the Aid flow (current US$) of Fragile and conflict affected situations in 2011 and the Aid flow (current US$) of Niger in 2012?
Give a very brief answer. 1.96e+09. What is the difference between the Aid flow (current US$) of Congo (Democratic) in 2011 and the Aid flow (current US$) of Niger in 2012?
Provide a succinct answer. 1.69e+08. What is the difference between the Aid flow (current US$) of Europe(all income levels) in 2011 and the Aid flow (current US$) of Fragile and conflict affected situations in 2013?
Your answer should be compact. -4.54e+09. What is the difference between the Aid flow (current US$) in Europe(all income levels) in 2011 and the Aid flow (current US$) in Congo (Democratic) in 2013?
Provide a short and direct response. 2.25e+08. What is the difference between the Aid flow (current US$) of Europe(all income levels) in 2011 and the Aid flow (current US$) of Niger in 2013?
Your response must be concise. 2.95e+08. What is the difference between the Aid flow (current US$) of Fragile and conflict affected situations in 2011 and the Aid flow (current US$) of Congo (Democratic) in 2013?
Make the answer very short. 1.88e+09. What is the difference between the Aid flow (current US$) in Fragile and conflict affected situations in 2011 and the Aid flow (current US$) in Niger in 2013?
Offer a terse response. 1.94e+09. What is the difference between the Aid flow (current US$) in Congo (Democratic) in 2011 and the Aid flow (current US$) in Niger in 2013?
Your answer should be compact. 1.52e+08. What is the difference between the Aid flow (current US$) in Europe(all income levels) in 2012 and the Aid flow (current US$) in Fragile and conflict affected situations in 2013?
Ensure brevity in your answer.  -4.59e+09. What is the difference between the Aid flow (current US$) in Europe(all income levels) in 2012 and the Aid flow (current US$) in Congo (Democratic) in 2013?
Your answer should be compact. 1.81e+08. What is the difference between the Aid flow (current US$) in Europe(all income levels) in 2012 and the Aid flow (current US$) in Niger in 2013?
Ensure brevity in your answer.  2.51e+08. What is the difference between the Aid flow (current US$) of Fragile and conflict affected situations in 2012 and the Aid flow (current US$) of Congo (Democratic) in 2013?
Provide a succinct answer. 1.95e+09. What is the difference between the Aid flow (current US$) of Fragile and conflict affected situations in 2012 and the Aid flow (current US$) of Niger in 2013?
Make the answer very short. 2.02e+09. What is the difference between the Aid flow (current US$) in Congo (Democratic) in 2012 and the Aid flow (current US$) in Niger in 2013?
Offer a very short reply. 5.94e+07. What is the average Aid flow (current US$) in Europe(all income levels) per year?
Offer a very short reply. 3.96e+08. What is the average Aid flow (current US$) of Fragile and conflict affected situations per year?
Provide a succinct answer. 2.09e+09. What is the average Aid flow (current US$) of Congo (Democratic) per year?
Ensure brevity in your answer.  7.84e+07. What is the average Aid flow (current US$) in Niger per year?
Provide a succinct answer. 2.32e+07. In the year 2006, what is the difference between the Aid flow (current US$) of Europe(all income levels) and Aid flow (current US$) of Fragile and conflict affected situations?
Your answer should be very brief. -1.09e+09. In the year 2006, what is the difference between the Aid flow (current US$) in Europe(all income levels) and Aid flow (current US$) in Congo (Democratic)?
Your response must be concise. 1.81e+08. In the year 2006, what is the difference between the Aid flow (current US$) in Europe(all income levels) and Aid flow (current US$) in Niger?
Your answer should be compact. 1.92e+08. In the year 2006, what is the difference between the Aid flow (current US$) of Fragile and conflict affected situations and Aid flow (current US$) of Congo (Democratic)?
Your response must be concise. 1.27e+09. In the year 2006, what is the difference between the Aid flow (current US$) of Fragile and conflict affected situations and Aid flow (current US$) of Niger?
Provide a succinct answer. 1.28e+09. In the year 2006, what is the difference between the Aid flow (current US$) in Congo (Democratic) and Aid flow (current US$) in Niger?
Provide a succinct answer. 1.11e+07. In the year 2007, what is the difference between the Aid flow (current US$) in Europe(all income levels) and Aid flow (current US$) in Fragile and conflict affected situations?
Provide a succinct answer. -1.00e+09. In the year 2007, what is the difference between the Aid flow (current US$) in Europe(all income levels) and Aid flow (current US$) in Congo (Democratic)?
Your answer should be compact. 3.39e+08. In the year 2007, what is the difference between the Aid flow (current US$) of Europe(all income levels) and Aid flow (current US$) of Niger?
Give a very brief answer. 3.34e+08. In the year 2007, what is the difference between the Aid flow (current US$) in Fragile and conflict affected situations and Aid flow (current US$) in Congo (Democratic)?
Offer a very short reply. 1.34e+09. In the year 2007, what is the difference between the Aid flow (current US$) of Fragile and conflict affected situations and Aid flow (current US$) of Niger?
Provide a short and direct response. 1.33e+09. In the year 2007, what is the difference between the Aid flow (current US$) in Congo (Democratic) and Aid flow (current US$) in Niger?
Your response must be concise. -5.35e+06. In the year 2008, what is the difference between the Aid flow (current US$) in Europe(all income levels) and Aid flow (current US$) in Fragile and conflict affected situations?
Provide a succinct answer. -1.94e+09. In the year 2008, what is the difference between the Aid flow (current US$) in Europe(all income levels) and Aid flow (current US$) in Congo (Democratic)?
Your response must be concise. 4.54e+08. In the year 2008, what is the difference between the Aid flow (current US$) in Europe(all income levels) and Aid flow (current US$) in Niger?
Make the answer very short. 4.89e+08. In the year 2008, what is the difference between the Aid flow (current US$) in Fragile and conflict affected situations and Aid flow (current US$) in Congo (Democratic)?
Keep it short and to the point. 2.39e+09. In the year 2008, what is the difference between the Aid flow (current US$) in Fragile and conflict affected situations and Aid flow (current US$) in Niger?
Your response must be concise. 2.42e+09. In the year 2008, what is the difference between the Aid flow (current US$) in Congo (Democratic) and Aid flow (current US$) in Niger?
Make the answer very short. 3.43e+07. In the year 2009, what is the difference between the Aid flow (current US$) of Europe(all income levels) and Aid flow (current US$) of Fragile and conflict affected situations?
Make the answer very short. -4.48e+08. In the year 2009, what is the difference between the Aid flow (current US$) of Europe(all income levels) and Aid flow (current US$) of Congo (Democratic)?
Your answer should be compact. 4.66e+08. In the year 2009, what is the difference between the Aid flow (current US$) of Europe(all income levels) and Aid flow (current US$) of Niger?
Provide a short and direct response. 4.96e+08. In the year 2009, what is the difference between the Aid flow (current US$) of Fragile and conflict affected situations and Aid flow (current US$) of Congo (Democratic)?
Your answer should be very brief. 9.14e+08. In the year 2009, what is the difference between the Aid flow (current US$) in Fragile and conflict affected situations and Aid flow (current US$) in Niger?
Ensure brevity in your answer.  9.45e+08. In the year 2009, what is the difference between the Aid flow (current US$) in Congo (Democratic) and Aid flow (current US$) in Niger?
Provide a short and direct response. 3.06e+07. In the year 2010, what is the difference between the Aid flow (current US$) of Europe(all income levels) and Aid flow (current US$) of Fragile and conflict affected situations?
Your answer should be very brief. -9.80e+08. In the year 2010, what is the difference between the Aid flow (current US$) of Europe(all income levels) and Aid flow (current US$) of Congo (Democratic)?
Offer a very short reply. 7.02e+08. In the year 2010, what is the difference between the Aid flow (current US$) of Europe(all income levels) and Aid flow (current US$) of Niger?
Offer a terse response. 7.57e+08. In the year 2010, what is the difference between the Aid flow (current US$) in Fragile and conflict affected situations and Aid flow (current US$) in Congo (Democratic)?
Your response must be concise. 1.68e+09. In the year 2010, what is the difference between the Aid flow (current US$) of Fragile and conflict affected situations and Aid flow (current US$) of Niger?
Your response must be concise. 1.74e+09. In the year 2010, what is the difference between the Aid flow (current US$) in Congo (Democratic) and Aid flow (current US$) in Niger?
Give a very brief answer. 5.48e+07. In the year 2011, what is the difference between the Aid flow (current US$) of Europe(all income levels) and Aid flow (current US$) of Fragile and conflict affected situations?
Your answer should be compact. -1.65e+09. In the year 2011, what is the difference between the Aid flow (current US$) in Europe(all income levels) and Aid flow (current US$) in Congo (Democratic)?
Make the answer very short. 1.42e+08. In the year 2011, what is the difference between the Aid flow (current US$) of Europe(all income levels) and Aid flow (current US$) of Niger?
Your response must be concise. 3.13e+08. In the year 2011, what is the difference between the Aid flow (current US$) of Fragile and conflict affected situations and Aid flow (current US$) of Congo (Democratic)?
Your response must be concise. 1.79e+09. In the year 2011, what is the difference between the Aid flow (current US$) in Fragile and conflict affected situations and Aid flow (current US$) in Niger?
Provide a succinct answer. 1.96e+09. In the year 2011, what is the difference between the Aid flow (current US$) in Congo (Democratic) and Aid flow (current US$) in Niger?
Your answer should be very brief. 1.71e+08. In the year 2012, what is the difference between the Aid flow (current US$) of Europe(all income levels) and Aid flow (current US$) of Fragile and conflict affected situations?
Make the answer very short. -1.77e+09. In the year 2012, what is the difference between the Aid flow (current US$) in Europe(all income levels) and Aid flow (current US$) in Congo (Democratic)?
Your response must be concise. 1.91e+08. In the year 2012, what is the difference between the Aid flow (current US$) in Europe(all income levels) and Aid flow (current US$) in Niger?
Provide a short and direct response. 2.67e+08. In the year 2012, what is the difference between the Aid flow (current US$) in Fragile and conflict affected situations and Aid flow (current US$) in Congo (Democratic)?
Your answer should be compact. 1.96e+09. In the year 2012, what is the difference between the Aid flow (current US$) of Fragile and conflict affected situations and Aid flow (current US$) of Niger?
Make the answer very short. 2.04e+09. In the year 2012, what is the difference between the Aid flow (current US$) in Congo (Democratic) and Aid flow (current US$) in Niger?
Your answer should be compact. 7.60e+07. In the year 2013, what is the difference between the Aid flow (current US$) of Europe(all income levels) and Aid flow (current US$) of Fragile and conflict affected situations?
Keep it short and to the point. -4.70e+09. In the year 2013, what is the difference between the Aid flow (current US$) of Europe(all income levels) and Aid flow (current US$) of Congo (Democratic)?
Provide a succinct answer. 6.80e+07. In the year 2013, what is the difference between the Aid flow (current US$) of Europe(all income levels) and Aid flow (current US$) of Niger?
Keep it short and to the point. 1.37e+08. In the year 2013, what is the difference between the Aid flow (current US$) of Fragile and conflict affected situations and Aid flow (current US$) of Congo (Democratic)?
Your answer should be very brief. 4.77e+09. In the year 2013, what is the difference between the Aid flow (current US$) in Fragile and conflict affected situations and Aid flow (current US$) in Niger?
Offer a very short reply. 4.84e+09. In the year 2013, what is the difference between the Aid flow (current US$) in Congo (Democratic) and Aid flow (current US$) in Niger?
Offer a very short reply. 6.93e+07. What is the ratio of the Aid flow (current US$) in Europe(all income levels) in 2006 to that in 2007?
Give a very brief answer. 0.56. What is the ratio of the Aid flow (current US$) in Fragile and conflict affected situations in 2006 to that in 2007?
Your answer should be compact. 0.95. What is the ratio of the Aid flow (current US$) of Niger in 2006 to that in 2007?
Keep it short and to the point. 0.43. What is the ratio of the Aid flow (current US$) of Europe(all income levels) in 2006 to that in 2008?
Ensure brevity in your answer.  0.4. What is the ratio of the Aid flow (current US$) of Fragile and conflict affected situations in 2006 to that in 2008?
Give a very brief answer. 0.53. What is the ratio of the Aid flow (current US$) in Congo (Democratic) in 2006 to that in 2008?
Ensure brevity in your answer.  0.45. What is the ratio of the Aid flow (current US$) of Niger in 2006 to that in 2008?
Your answer should be very brief. 0.71. What is the ratio of the Aid flow (current US$) of Europe(all income levels) in 2006 to that in 2009?
Keep it short and to the point. 0.38. What is the ratio of the Aid flow (current US$) in Fragile and conflict affected situations in 2006 to that in 2009?
Your response must be concise. 1.32. What is the ratio of the Aid flow (current US$) in Congo (Democratic) in 2006 to that in 2009?
Ensure brevity in your answer.  0.35. What is the ratio of the Aid flow (current US$) of Niger in 2006 to that in 2009?
Give a very brief answer. 0.34. What is the ratio of the Aid flow (current US$) in Europe(all income levels) in 2006 to that in 2010?
Provide a succinct answer. 0.26. What is the ratio of the Aid flow (current US$) of Fragile and conflict affected situations in 2006 to that in 2010?
Ensure brevity in your answer.  0.73. What is the ratio of the Aid flow (current US$) of Congo (Democratic) in 2006 to that in 2010?
Provide a succinct answer. 0.29. What is the ratio of the Aid flow (current US$) in Niger in 2006 to that in 2010?
Keep it short and to the point. 0.48. What is the ratio of the Aid flow (current US$) of Europe(all income levels) in 2006 to that in 2011?
Your answer should be compact. 0.62. What is the ratio of the Aid flow (current US$) of Fragile and conflict affected situations in 2006 to that in 2011?
Offer a terse response. 0.65. What is the ratio of the Aid flow (current US$) of Congo (Democratic) in 2006 to that in 2011?
Make the answer very short. 0.12. What is the ratio of the Aid flow (current US$) in Niger in 2006 to that in 2011?
Make the answer very short. 0.76. What is the ratio of the Aid flow (current US$) of Europe(all income levels) in 2006 to that in 2012?
Give a very brief answer. 0.72. What is the ratio of the Aid flow (current US$) of Fragile and conflict affected situations in 2006 to that in 2012?
Your answer should be very brief. 0.63. What is the ratio of the Aid flow (current US$) in Congo (Democratic) in 2006 to that in 2012?
Your answer should be very brief. 0.25. What is the ratio of the Aid flow (current US$) in Niger in 2006 to that in 2012?
Your answer should be compact. 0.68. What is the ratio of the Aid flow (current US$) in Europe(all income levels) in 2006 to that in 2013?
Provide a short and direct response. 1.19. What is the ratio of the Aid flow (current US$) in Fragile and conflict affected situations in 2006 to that in 2013?
Provide a succinct answer. 0.27. What is the ratio of the Aid flow (current US$) in Congo (Democratic) in 2006 to that in 2013?
Your answer should be compact. 0.22. What is the ratio of the Aid flow (current US$) of Niger in 2006 to that in 2013?
Make the answer very short. 0.35. What is the ratio of the Aid flow (current US$) of Europe(all income levels) in 2007 to that in 2008?
Offer a terse response. 0.72. What is the ratio of the Aid flow (current US$) of Fragile and conflict affected situations in 2007 to that in 2008?
Your answer should be compact. 0.56. What is the ratio of the Aid flow (current US$) of Congo (Democratic) in 2007 to that in 2008?
Offer a terse response. 0.45. What is the ratio of the Aid flow (current US$) of Niger in 2007 to that in 2008?
Offer a very short reply. 1.67. What is the ratio of the Aid flow (current US$) in Europe(all income levels) in 2007 to that in 2009?
Offer a very short reply. 0.68. What is the ratio of the Aid flow (current US$) of Fragile and conflict affected situations in 2007 to that in 2009?
Your response must be concise. 1.39. What is the ratio of the Aid flow (current US$) in Congo (Democratic) in 2007 to that in 2009?
Your answer should be very brief. 0.35. What is the ratio of the Aid flow (current US$) of Niger in 2007 to that in 2009?
Give a very brief answer. 0.81. What is the ratio of the Aid flow (current US$) in Europe(all income levels) in 2007 to that in 2010?
Your answer should be compact. 0.46. What is the ratio of the Aid flow (current US$) of Fragile and conflict affected situations in 2007 to that in 2010?
Provide a short and direct response. 0.77. What is the ratio of the Aid flow (current US$) of Congo (Democratic) in 2007 to that in 2010?
Provide a succinct answer. 0.29. What is the ratio of the Aid flow (current US$) of Niger in 2007 to that in 2010?
Provide a succinct answer. 1.12. What is the ratio of the Aid flow (current US$) in Europe(all income levels) in 2007 to that in 2011?
Your response must be concise. 1.1. What is the ratio of the Aid flow (current US$) of Fragile and conflict affected situations in 2007 to that in 2011?
Keep it short and to the point. 0.69. What is the ratio of the Aid flow (current US$) of Congo (Democratic) in 2007 to that in 2011?
Your answer should be very brief. 0.12. What is the ratio of the Aid flow (current US$) of Niger in 2007 to that in 2011?
Offer a terse response. 1.78. What is the ratio of the Aid flow (current US$) in Europe(all income levels) in 2007 to that in 2012?
Give a very brief answer. 1.27. What is the ratio of the Aid flow (current US$) in Fragile and conflict affected situations in 2007 to that in 2012?
Make the answer very short. 0.66. What is the ratio of the Aid flow (current US$) of Congo (Democratic) in 2007 to that in 2012?
Keep it short and to the point. 0.24. What is the ratio of the Aid flow (current US$) of Niger in 2007 to that in 2012?
Ensure brevity in your answer.  1.58. What is the ratio of the Aid flow (current US$) of Europe(all income levels) in 2007 to that in 2013?
Offer a very short reply. 2.11. What is the ratio of the Aid flow (current US$) of Fragile and conflict affected situations in 2007 to that in 2013?
Give a very brief answer. 0.28. What is the ratio of the Aid flow (current US$) in Congo (Democratic) in 2007 to that in 2013?
Make the answer very short. 0.22. What is the ratio of the Aid flow (current US$) in Niger in 2007 to that in 2013?
Your response must be concise. 0.82. What is the ratio of the Aid flow (current US$) in Europe(all income levels) in 2008 to that in 2009?
Offer a very short reply. 0.95. What is the ratio of the Aid flow (current US$) in Fragile and conflict affected situations in 2008 to that in 2009?
Ensure brevity in your answer.  2.49. What is the ratio of the Aid flow (current US$) in Congo (Democratic) in 2008 to that in 2009?
Ensure brevity in your answer.  0.78. What is the ratio of the Aid flow (current US$) of Niger in 2008 to that in 2009?
Provide a succinct answer. 0.48. What is the ratio of the Aid flow (current US$) of Europe(all income levels) in 2008 to that in 2010?
Keep it short and to the point. 0.65. What is the ratio of the Aid flow (current US$) of Fragile and conflict affected situations in 2008 to that in 2010?
Your answer should be compact. 1.39. What is the ratio of the Aid flow (current US$) of Congo (Democratic) in 2008 to that in 2010?
Offer a terse response. 0.64. What is the ratio of the Aid flow (current US$) in Niger in 2008 to that in 2010?
Make the answer very short. 0.67. What is the ratio of the Aid flow (current US$) in Europe(all income levels) in 2008 to that in 2011?
Your answer should be very brief. 1.54. What is the ratio of the Aid flow (current US$) in Fragile and conflict affected situations in 2008 to that in 2011?
Offer a terse response. 1.23. What is the ratio of the Aid flow (current US$) in Congo (Democratic) in 2008 to that in 2011?
Your answer should be very brief. 0.27. What is the ratio of the Aid flow (current US$) in Niger in 2008 to that in 2011?
Offer a terse response. 1.07. What is the ratio of the Aid flow (current US$) in Europe(all income levels) in 2008 to that in 2012?
Offer a very short reply. 1.77. What is the ratio of the Aid flow (current US$) in Fragile and conflict affected situations in 2008 to that in 2012?
Your answer should be very brief. 1.19. What is the ratio of the Aid flow (current US$) of Congo (Democratic) in 2008 to that in 2012?
Give a very brief answer. 0.55. What is the ratio of the Aid flow (current US$) in Niger in 2008 to that in 2012?
Your answer should be compact. 0.95. What is the ratio of the Aid flow (current US$) in Europe(all income levels) in 2008 to that in 2013?
Your answer should be compact. 2.94. What is the ratio of the Aid flow (current US$) of Fragile and conflict affected situations in 2008 to that in 2013?
Your answer should be very brief. 0.5. What is the ratio of the Aid flow (current US$) of Congo (Democratic) in 2008 to that in 2013?
Offer a very short reply. 0.49. What is the ratio of the Aid flow (current US$) in Niger in 2008 to that in 2013?
Offer a very short reply. 0.49. What is the ratio of the Aid flow (current US$) in Europe(all income levels) in 2009 to that in 2010?
Your answer should be very brief. 0.68. What is the ratio of the Aid flow (current US$) of Fragile and conflict affected situations in 2009 to that in 2010?
Provide a short and direct response. 0.56. What is the ratio of the Aid flow (current US$) in Congo (Democratic) in 2009 to that in 2010?
Keep it short and to the point. 0.82. What is the ratio of the Aid flow (current US$) of Niger in 2009 to that in 2010?
Offer a very short reply. 1.39. What is the ratio of the Aid flow (current US$) in Europe(all income levels) in 2009 to that in 2011?
Offer a very short reply. 1.61. What is the ratio of the Aid flow (current US$) in Fragile and conflict affected situations in 2009 to that in 2011?
Provide a succinct answer. 0.49. What is the ratio of the Aid flow (current US$) of Congo (Democratic) in 2009 to that in 2011?
Make the answer very short. 0.35. What is the ratio of the Aid flow (current US$) of Niger in 2009 to that in 2011?
Make the answer very short. 2.21. What is the ratio of the Aid flow (current US$) in Europe(all income levels) in 2009 to that in 2012?
Provide a succinct answer. 1.86. What is the ratio of the Aid flow (current US$) in Fragile and conflict affected situations in 2009 to that in 2012?
Your response must be concise. 0.48. What is the ratio of the Aid flow (current US$) in Congo (Democratic) in 2009 to that in 2012?
Offer a very short reply. 0.7. What is the ratio of the Aid flow (current US$) of Niger in 2009 to that in 2012?
Provide a short and direct response. 1.96. What is the ratio of the Aid flow (current US$) in Europe(all income levels) in 2009 to that in 2013?
Keep it short and to the point. 3.09. What is the ratio of the Aid flow (current US$) of Fragile and conflict affected situations in 2009 to that in 2013?
Give a very brief answer. 0.2. What is the ratio of the Aid flow (current US$) of Congo (Democratic) in 2009 to that in 2013?
Offer a very short reply. 0.63. What is the ratio of the Aid flow (current US$) in Niger in 2009 to that in 2013?
Offer a terse response. 1.02. What is the ratio of the Aid flow (current US$) in Europe(all income levels) in 2010 to that in 2011?
Offer a terse response. 2.38. What is the ratio of the Aid flow (current US$) in Fragile and conflict affected situations in 2010 to that in 2011?
Offer a very short reply. 0.89. What is the ratio of the Aid flow (current US$) in Congo (Democratic) in 2010 to that in 2011?
Offer a very short reply. 0.43. What is the ratio of the Aid flow (current US$) of Niger in 2010 to that in 2011?
Your response must be concise. 1.59. What is the ratio of the Aid flow (current US$) in Europe(all income levels) in 2010 to that in 2012?
Keep it short and to the point. 2.74. What is the ratio of the Aid flow (current US$) of Fragile and conflict affected situations in 2010 to that in 2012?
Give a very brief answer. 0.86. What is the ratio of the Aid flow (current US$) in Congo (Democratic) in 2010 to that in 2012?
Your response must be concise. 0.85. What is the ratio of the Aid flow (current US$) of Niger in 2010 to that in 2012?
Offer a terse response. 1.41. What is the ratio of the Aid flow (current US$) in Europe(all income levels) in 2010 to that in 2013?
Provide a succinct answer. 4.55. What is the ratio of the Aid flow (current US$) in Fragile and conflict affected situations in 2010 to that in 2013?
Your answer should be very brief. 0.36. What is the ratio of the Aid flow (current US$) of Congo (Democratic) in 2010 to that in 2013?
Make the answer very short. 0.77. What is the ratio of the Aid flow (current US$) in Niger in 2010 to that in 2013?
Keep it short and to the point. 0.73. What is the ratio of the Aid flow (current US$) in Europe(all income levels) in 2011 to that in 2012?
Ensure brevity in your answer.  1.15. What is the ratio of the Aid flow (current US$) of Fragile and conflict affected situations in 2011 to that in 2012?
Your response must be concise. 0.96. What is the ratio of the Aid flow (current US$) of Congo (Democratic) in 2011 to that in 2012?
Provide a succinct answer. 1.99. What is the ratio of the Aid flow (current US$) in Niger in 2011 to that in 2012?
Provide a short and direct response. 0.89. What is the ratio of the Aid flow (current US$) of Europe(all income levels) in 2011 to that in 2013?
Make the answer very short. 1.92. What is the ratio of the Aid flow (current US$) in Fragile and conflict affected situations in 2011 to that in 2013?
Give a very brief answer. 0.41. What is the ratio of the Aid flow (current US$) of Congo (Democratic) in 2011 to that in 2013?
Your response must be concise. 1.8. What is the ratio of the Aid flow (current US$) in Niger in 2011 to that in 2013?
Provide a succinct answer. 0.46. What is the ratio of the Aid flow (current US$) of Europe(all income levels) in 2012 to that in 2013?
Ensure brevity in your answer.  1.66. What is the ratio of the Aid flow (current US$) in Fragile and conflict affected situations in 2012 to that in 2013?
Your answer should be compact. 0.42. What is the ratio of the Aid flow (current US$) in Congo (Democratic) in 2012 to that in 2013?
Offer a terse response. 0.9. What is the ratio of the Aid flow (current US$) of Niger in 2012 to that in 2013?
Keep it short and to the point. 0.52. What is the difference between the highest and the second highest Aid flow (current US$) of Europe(all income levels)?
Ensure brevity in your answer.  2.51e+08. What is the difference between the highest and the second highest Aid flow (current US$) of Fragile and conflict affected situations?
Offer a very short reply. 2.43e+09. What is the difference between the highest and the second highest Aid flow (current US$) in Congo (Democratic)?
Offer a very short reply. 8.30e+07. What is the difference between the highest and the second highest Aid flow (current US$) of Niger?
Provide a succinct answer. 5.90e+05. What is the difference between the highest and the lowest Aid flow (current US$) in Europe(all income levels)?
Your answer should be very brief. 6.10e+08. What is the difference between the highest and the lowest Aid flow (current US$) in Fragile and conflict affected situations?
Provide a succinct answer. 3.89e+09. What is the difference between the highest and the lowest Aid flow (current US$) in Congo (Democratic)?
Offer a very short reply. 1.64e+08. What is the difference between the highest and the lowest Aid flow (current US$) of Niger?
Make the answer very short. 2.30e+07. 